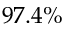Convert formula to latex. <formula><loc_0><loc_0><loc_500><loc_500>9 7 . 4 \%</formula> 